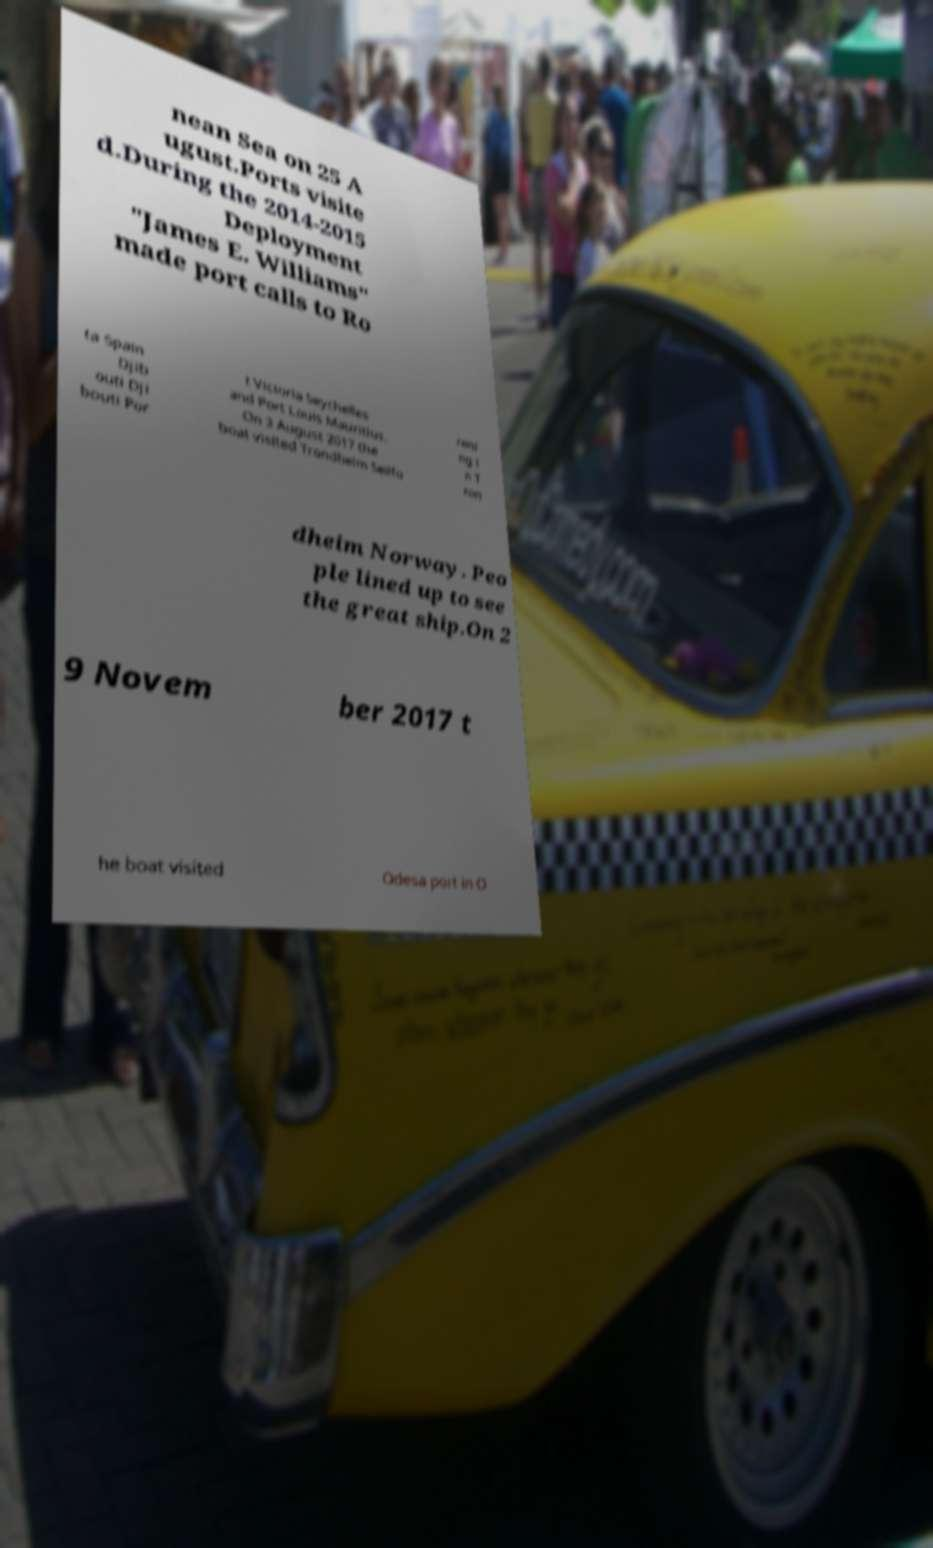Could you assist in decoding the text presented in this image and type it out clearly? nean Sea on 25 A ugust.Ports visite d.During the 2014-2015 Deployment "James E. Williams" made port calls to Ro ta Spain Djib outi Dji bouti Por t Victoria Seychelles and Port Louis Mauritius. On 3 August 2017 the boat visited Trondheim Seilfo reni ng i n T ron dheim Norway. Peo ple lined up to see the great ship.On 2 9 Novem ber 2017 t he boat visited Odesa port in O 